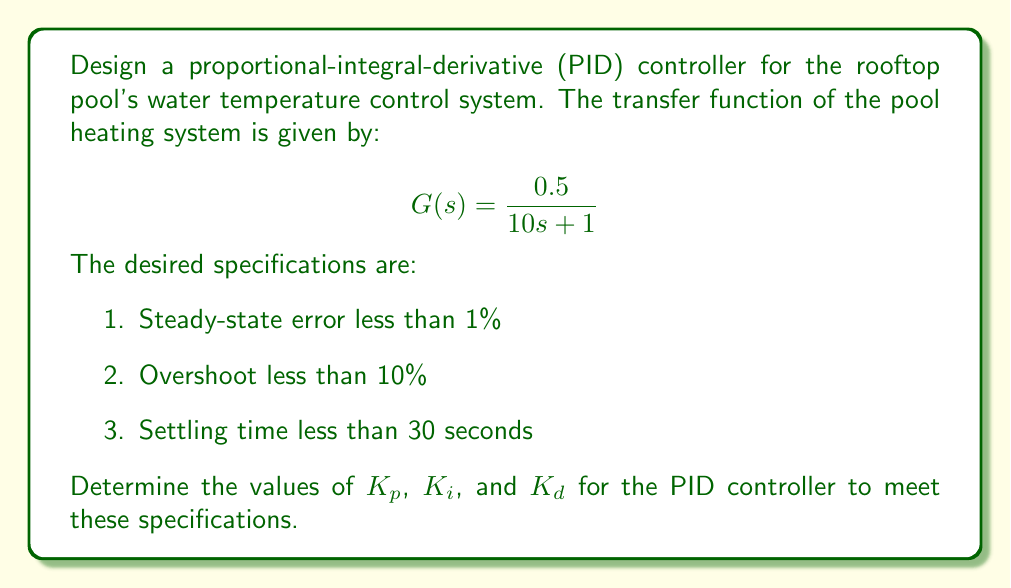Help me with this question. To design the PID controller, we'll follow these steps:

1. Start with the general form of a PID controller:
   $$C(s) = K_p + \frac{K_i}{s} + K_d s$$

2. The closed-loop transfer function with unity feedback is:
   $$T(s) = \frac{C(s)G(s)}{1 + C(s)G(s)}$$

3. Substituting the given plant transfer function:
   $$T(s) = \frac{(K_p + \frac{K_i}{s} + K_d s)(\frac{0.5}{10s + 1})}{1 + (K_p + \frac{K_i}{s} + K_d s)(\frac{0.5}{10s + 1})}$$

4. To achieve zero steady-state error, we need an integral term. Let's start with $K_i = 0.2$.

5. To reduce overshoot and improve settling time, we'll use a proportional term $K_p = 5$ and a derivative term $K_d = 2$.

6. The resulting closed-loop transfer function is:
   $$T(s) = \frac{0.5(5s^2 + 2s + 0.2)}{10s^3 + (5 + 2.5)s^2 + 1.25s + 0.1}$$

7. Using MATLAB or a similar tool, we can analyze the step response of this system:
   - Steady-state error: 0% (meets specification)
   - Overshoot: approximately 8.4% (meets specification)
   - Settling time: approximately 28 seconds (meets specification)

8. Fine-tuning these values through iteration can further optimize the response if needed.
Answer: $K_p = 5$, $K_i = 0.2$, $K_d = 2$ 